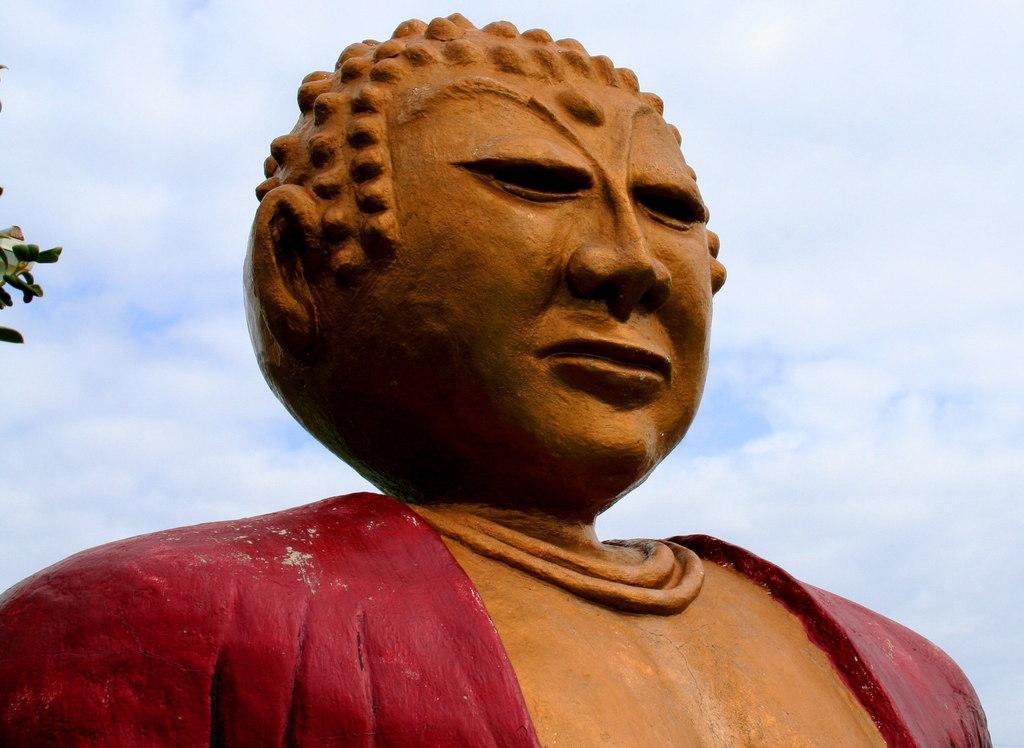How would you summarize this image in a sentence or two? Here in this picture we can see a statue present and we can see the sky is fully covered with clouds and on the left side we can see leaves present. 